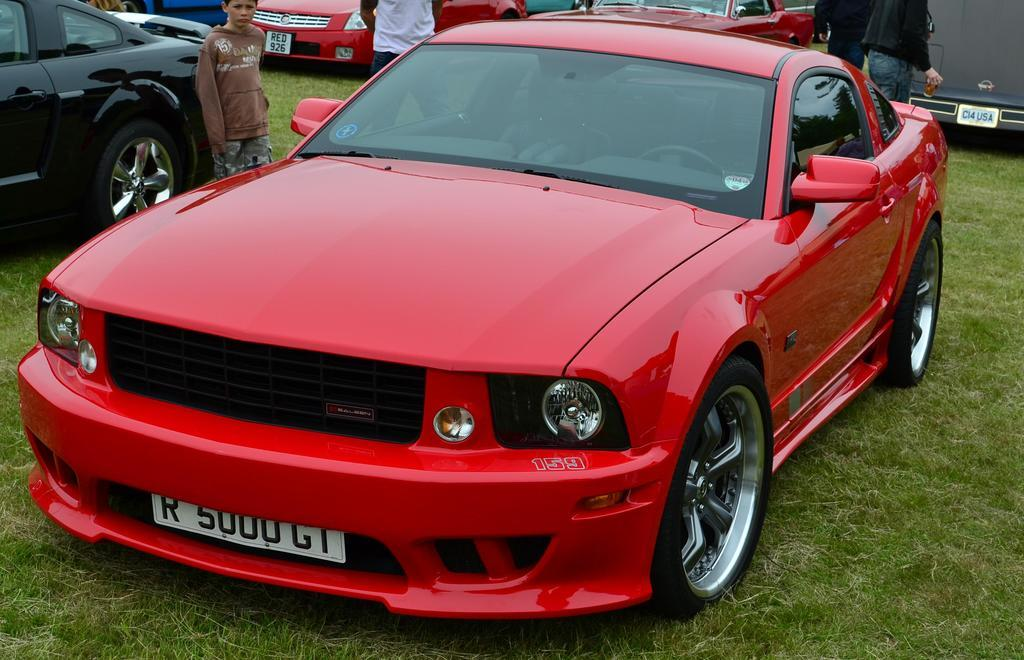What can be seen in the image? There are vehicles in the image. Can you describe one of the vehicles? One of the vehicles is red. What else is visible in the background of the image? There are people standing in the background. What color is the grass in the image? The grass is green in color. What type of pancake is being served to the boy in the image? There is no boy or pancake present in the image. 